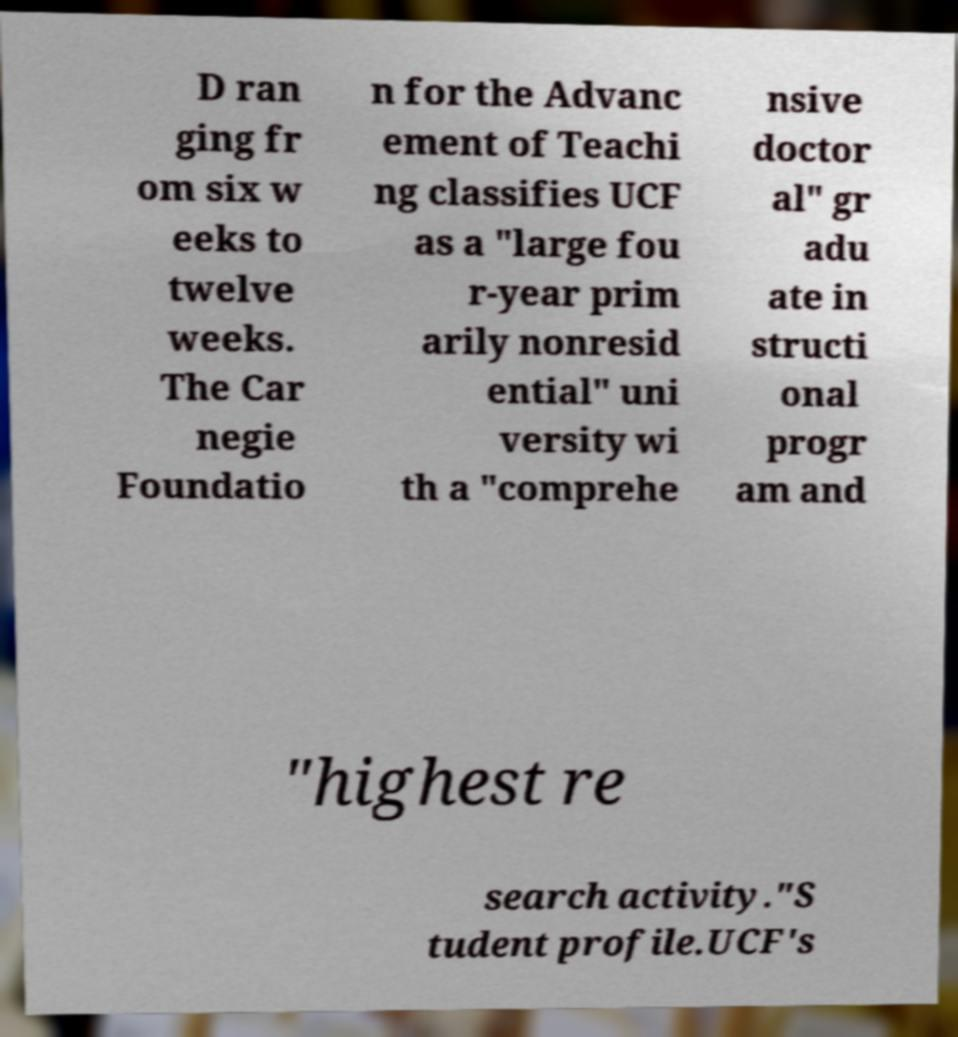Please identify and transcribe the text found in this image. D ran ging fr om six w eeks to twelve weeks. The Car negie Foundatio n for the Advanc ement of Teachi ng classifies UCF as a "large fou r-year prim arily nonresid ential" uni versity wi th a "comprehe nsive doctor al" gr adu ate in structi onal progr am and "highest re search activity."S tudent profile.UCF's 